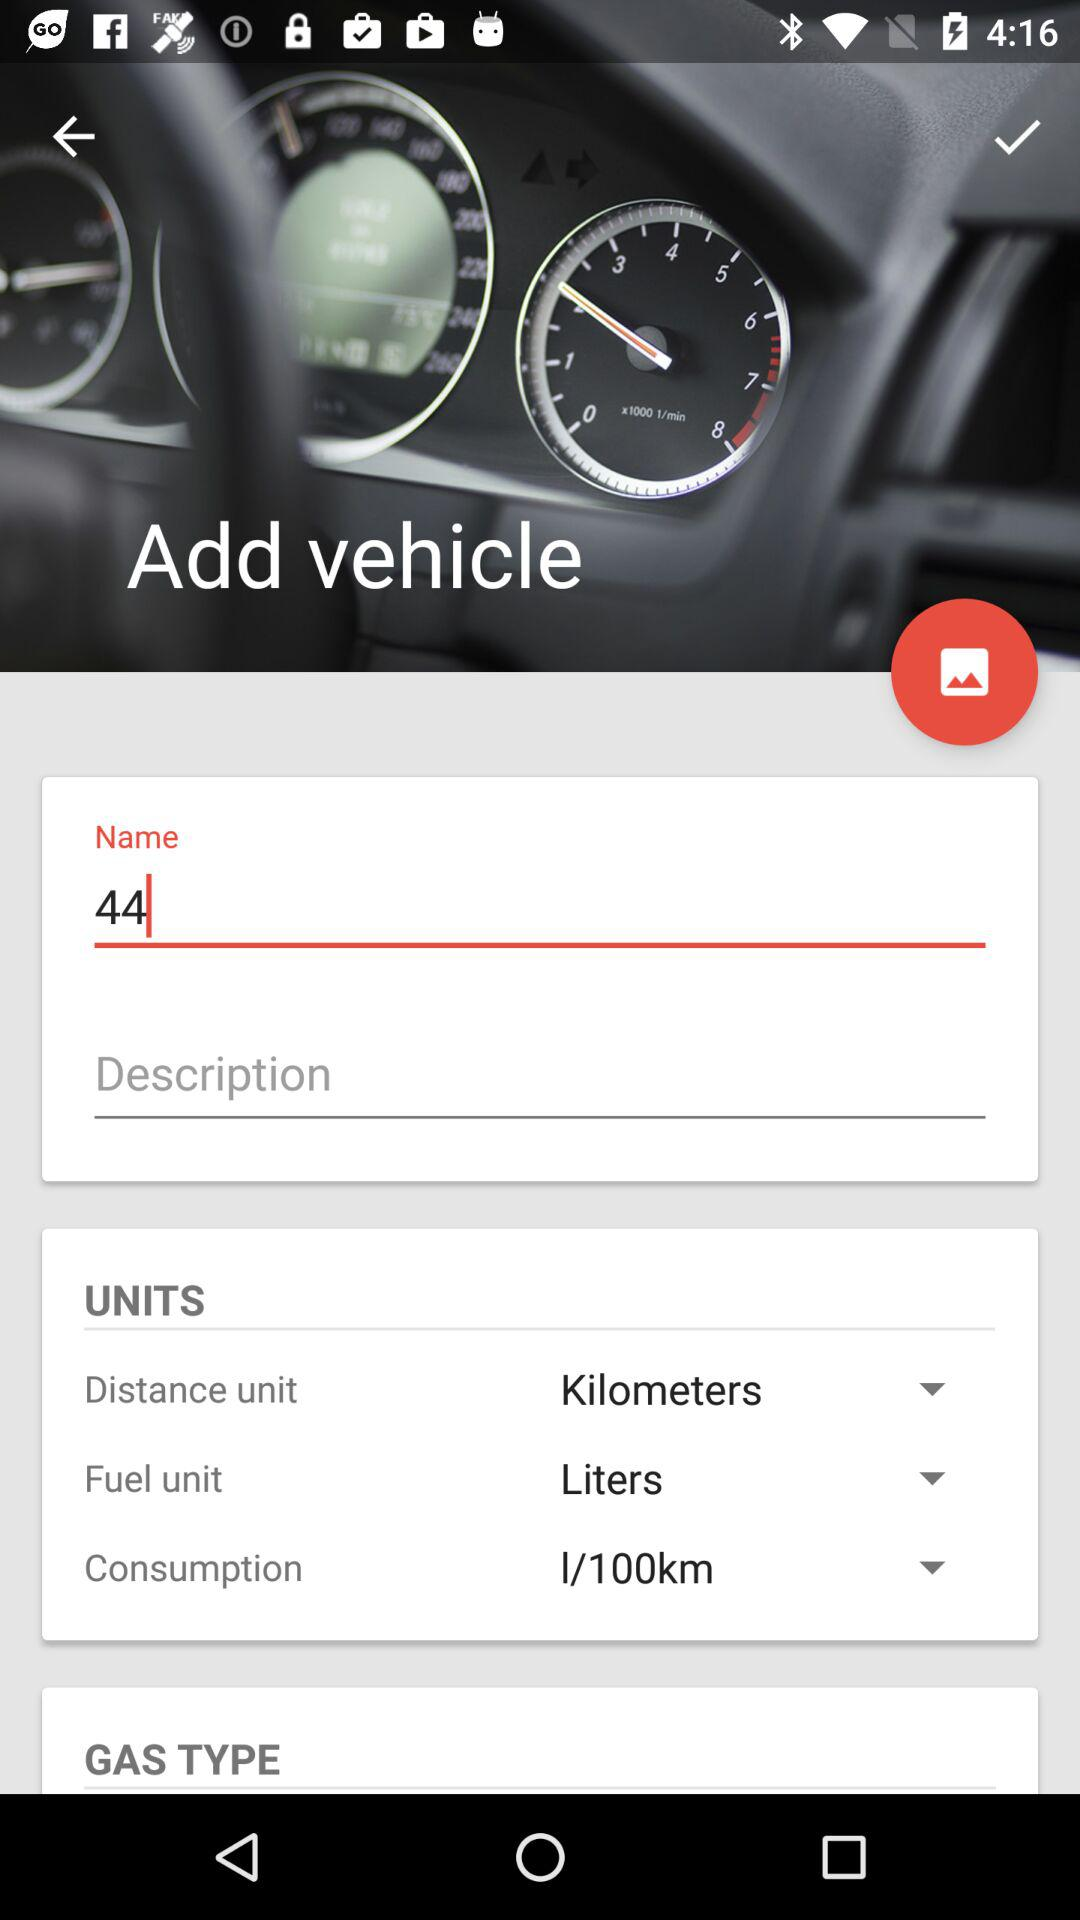What is the unit of fuel? The unit of fuel is liters. 